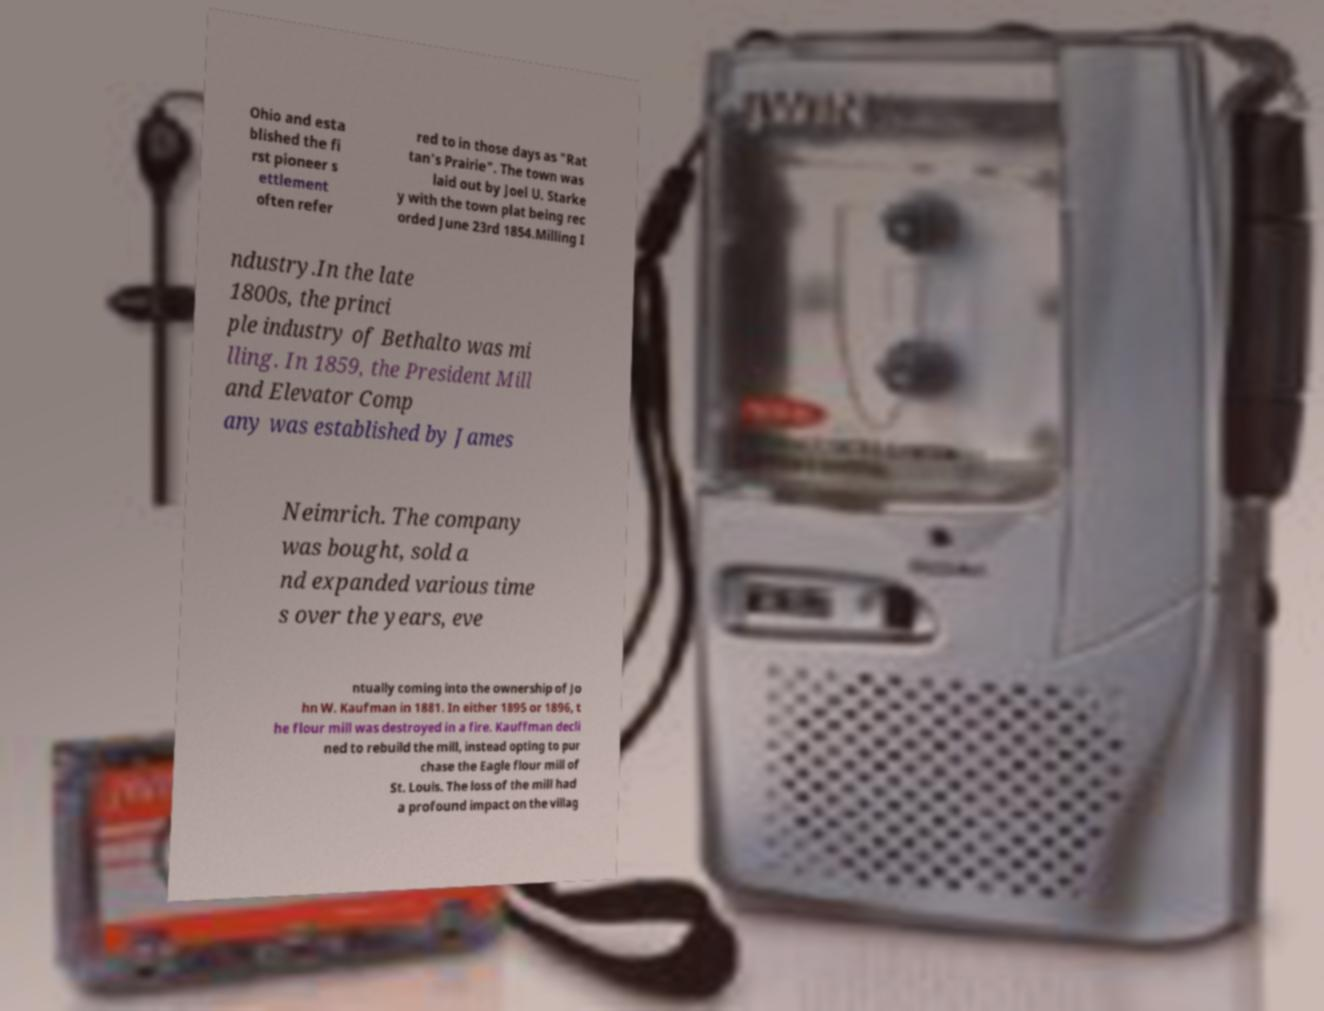For documentation purposes, I need the text within this image transcribed. Could you provide that? Ohio and esta blished the fi rst pioneer s ettlement often refer red to in those days as "Rat tan's Prairie". The town was laid out by Joel U. Starke y with the town plat being rec orded June 23rd 1854.Milling I ndustry.In the late 1800s, the princi ple industry of Bethalto was mi lling. In 1859, the President Mill and Elevator Comp any was established by James Neimrich. The company was bought, sold a nd expanded various time s over the years, eve ntually coming into the ownership of Jo hn W. Kaufman in 1881. In either 1895 or 1896, t he flour mill was destroyed in a fire. Kauffman decli ned to rebuild the mill, instead opting to pur chase the Eagle flour mill of St. Louis. The loss of the mill had a profound impact on the villag 